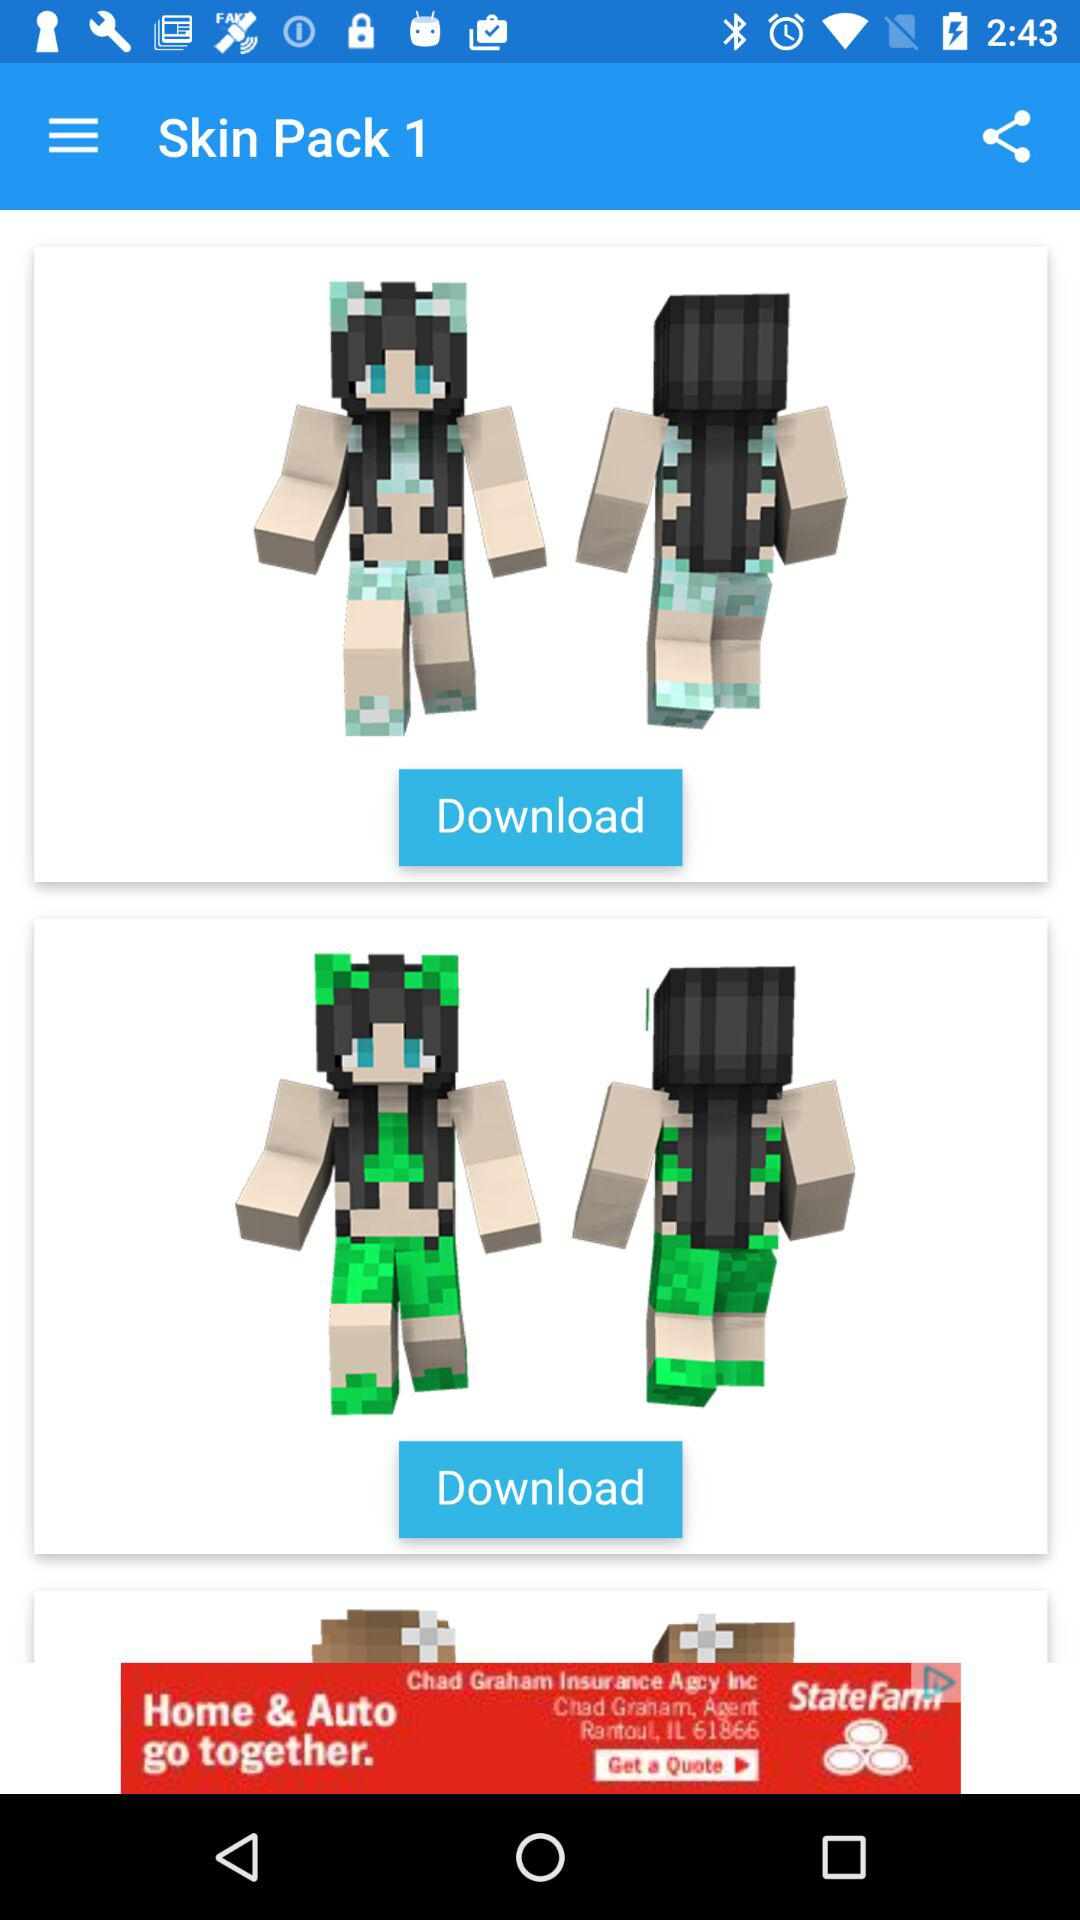How many more skins are there than banners?
Answer the question using a single word or phrase. 2 